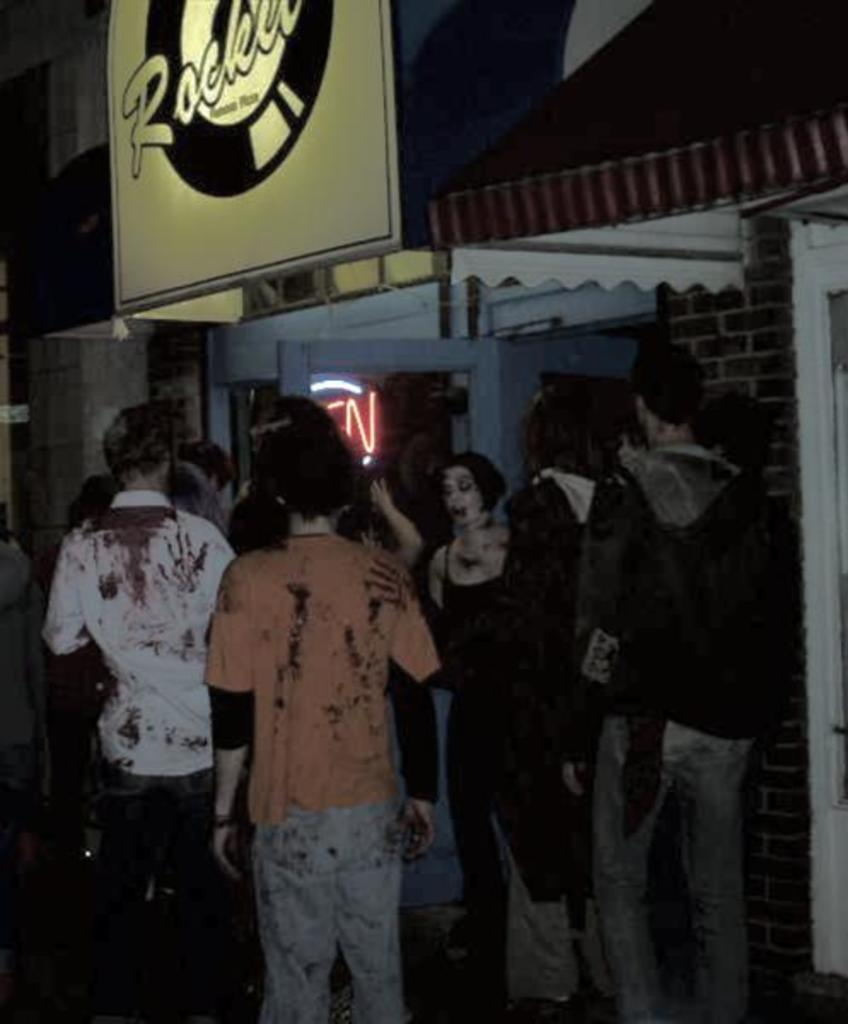What can be observed about the attire of the persons in the image? There are persons in different color dresses in the image. What are the persons doing in the image? The persons are standing. What is located above the persons in the image? There is a hoarding above the persons. What can be seen in the background of the image? There is a building in the background of the image. How many dogs are sitting on the bike in the image? There is no bike or dogs present in the image. What type of twig can be seen in the hands of the persons in the image? There is no twig visible in the hands of the persons in the image. 